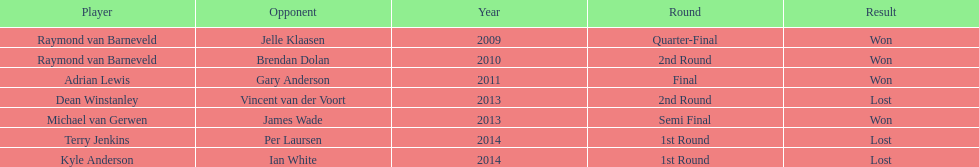How many champions were from norway? 0. 